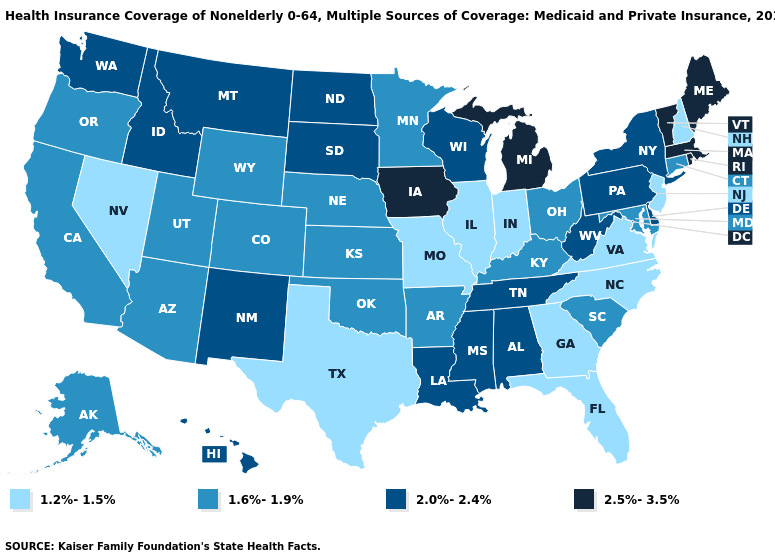Among the states that border Kentucky , does Ohio have the lowest value?
Keep it brief. No. What is the value of New Jersey?
Keep it brief. 1.2%-1.5%. Which states have the lowest value in the USA?
Answer briefly. Florida, Georgia, Illinois, Indiana, Missouri, Nevada, New Hampshire, New Jersey, North Carolina, Texas, Virginia. What is the value of Maryland?
Concise answer only. 1.6%-1.9%. Name the states that have a value in the range 2.0%-2.4%?
Quick response, please. Alabama, Delaware, Hawaii, Idaho, Louisiana, Mississippi, Montana, New Mexico, New York, North Dakota, Pennsylvania, South Dakota, Tennessee, Washington, West Virginia, Wisconsin. Does Alaska have the same value as Connecticut?
Quick response, please. Yes. What is the lowest value in states that border Wisconsin?
Answer briefly. 1.2%-1.5%. Does Delaware have the lowest value in the USA?
Write a very short answer. No. Name the states that have a value in the range 1.6%-1.9%?
Short answer required. Alaska, Arizona, Arkansas, California, Colorado, Connecticut, Kansas, Kentucky, Maryland, Minnesota, Nebraska, Ohio, Oklahoma, Oregon, South Carolina, Utah, Wyoming. Does Nevada have the highest value in the USA?
Give a very brief answer. No. What is the value of Arizona?
Keep it brief. 1.6%-1.9%. Which states hav the highest value in the Northeast?
Be succinct. Maine, Massachusetts, Rhode Island, Vermont. Name the states that have a value in the range 2.0%-2.4%?
Write a very short answer. Alabama, Delaware, Hawaii, Idaho, Louisiana, Mississippi, Montana, New Mexico, New York, North Dakota, Pennsylvania, South Dakota, Tennessee, Washington, West Virginia, Wisconsin. Does Ohio have the same value as Maryland?
Short answer required. Yes. Does the map have missing data?
Keep it brief. No. 